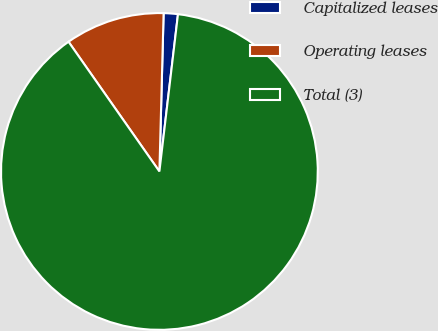Convert chart to OTSL. <chart><loc_0><loc_0><loc_500><loc_500><pie_chart><fcel>Capitalized leases<fcel>Operating leases<fcel>Total (3)<nl><fcel>1.45%<fcel>10.15%<fcel>88.4%<nl></chart> 